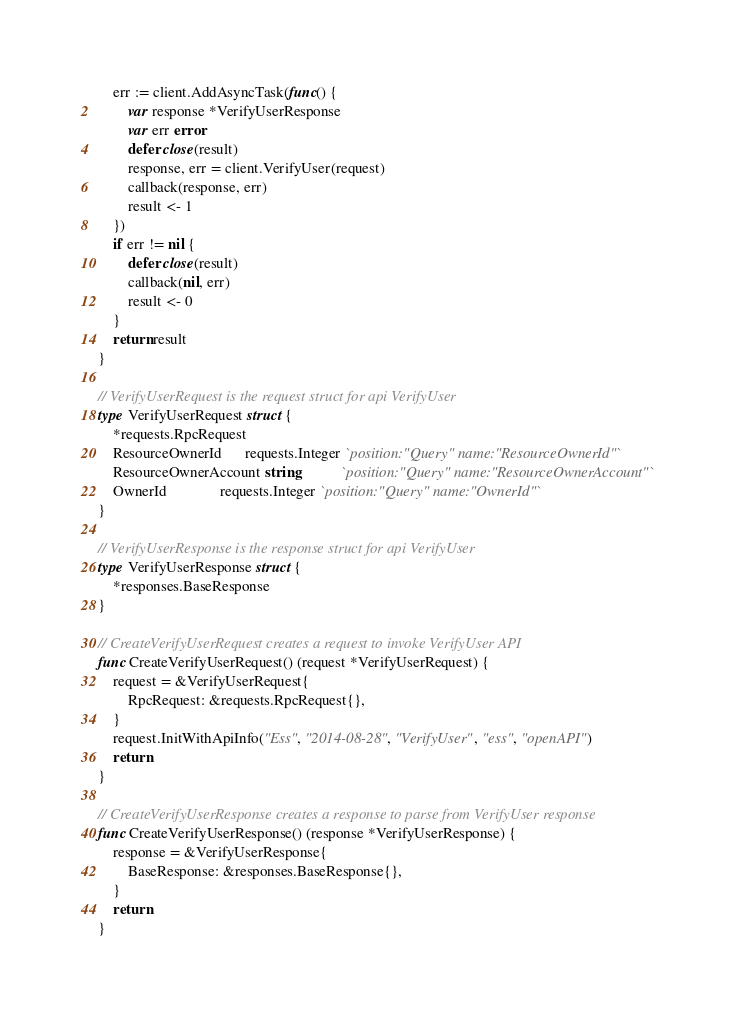Convert code to text. <code><loc_0><loc_0><loc_500><loc_500><_Go_>	err := client.AddAsyncTask(func() {
		var response *VerifyUserResponse
		var err error
		defer close(result)
		response, err = client.VerifyUser(request)
		callback(response, err)
		result <- 1
	})
	if err != nil {
		defer close(result)
		callback(nil, err)
		result <- 0
	}
	return result
}

// VerifyUserRequest is the request struct for api VerifyUser
type VerifyUserRequest struct {
	*requests.RpcRequest
	ResourceOwnerId      requests.Integer `position:"Query" name:"ResourceOwnerId"`
	ResourceOwnerAccount string           `position:"Query" name:"ResourceOwnerAccount"`
	OwnerId              requests.Integer `position:"Query" name:"OwnerId"`
}

// VerifyUserResponse is the response struct for api VerifyUser
type VerifyUserResponse struct {
	*responses.BaseResponse
}

// CreateVerifyUserRequest creates a request to invoke VerifyUser API
func CreateVerifyUserRequest() (request *VerifyUserRequest) {
	request = &VerifyUserRequest{
		RpcRequest: &requests.RpcRequest{},
	}
	request.InitWithApiInfo("Ess", "2014-08-28", "VerifyUser", "ess", "openAPI")
	return
}

// CreateVerifyUserResponse creates a response to parse from VerifyUser response
func CreateVerifyUserResponse() (response *VerifyUserResponse) {
	response = &VerifyUserResponse{
		BaseResponse: &responses.BaseResponse{},
	}
	return
}
</code> 